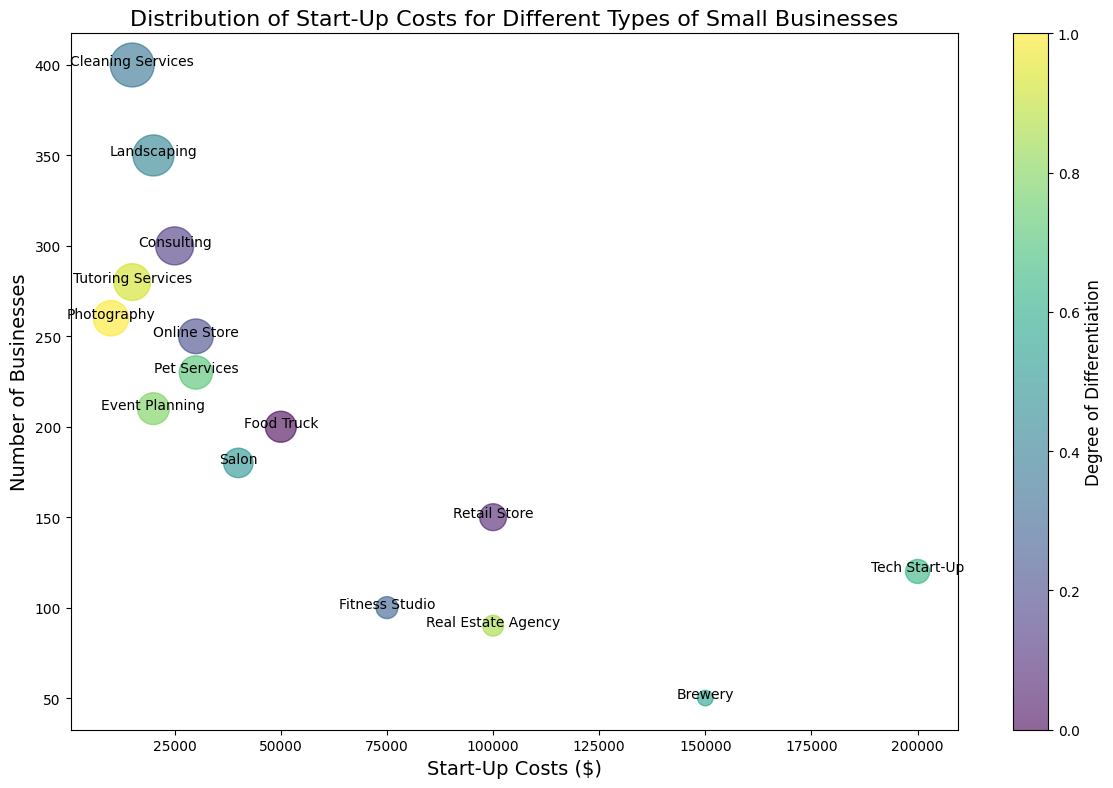What is the startup cost for the business type with the highest number of businesses? First, identify the bubble with the highest y-axis value (Number of Businesses). This is for Cleaning Services with 400 businesses. Then, locate its corresponding x-axis value (Start-Up Costs).
Answer: 15000 Which business type has the highest startup cost? Look for the bubble farthest to the right on the x-axis, which corresponds to the highest start-up cost. This is the Tech Start-Up with a cost of $200,000.
Answer: Tech Start-Up Which business type in an urban location has the lowest startup costs? Identify bubbles in urban locations and find the one with the lowest x-axis value (Start-Up Costs). For Urban, Photography has the lowest startup cost of $10,000.
Answer: Photography How many more businesses are in online stores compared to breweries? Find the y-axis values for both Online Store (250) and Brewery (50). Subtract the smaller value from the larger one: 250 - 50 = 200.
Answer: 200 Which has more businesses, Food Trucks or Pet Services? Compare the y-axis values of Food Truck (200) and Pet Services (230). Pet Services has more businesses.
Answer: Pet Services What is the average start-up cost of the following types: Retail Store, Fitness Studio, and Real Estate Agency? Add the start-up costs of Retail Store ($100,000), Fitness Studio ($75,000), and Real Estate Agency ($100,000), then divide by 3. Average cost: (100000 + 75000 + 100000) / 3 = $91,667.
Answer: $91,667 Which business type has the largest bubble and where is it located? The largest bubble corresponds to the highest number of businesses, which is Cleaning Services with 400 businesses, located in Urban areas.
Answer: Cleaning Services, Urban Which business type has the same number of businesses as the number of businesses in Landscaping? Landscaping has 350 businesses. The business type with the same number of businesses is not available.
Answer: None Among the suburban businesses, which one requires the highest start-up costs? Identify the bubbles representing suburban locations and find the one with the highest x-axis value (Start-Up Costs). The Brewery in suburban areas has the highest cost of $150,000.
Answer: Brewery What is the total number of businesses for Event Planning and Tutoring Services combined? Add the number of businesses (y-values) for Event Planning (210) and Tutoring Services (280). Total: 210 + 280 = 490.
Answer: 490 